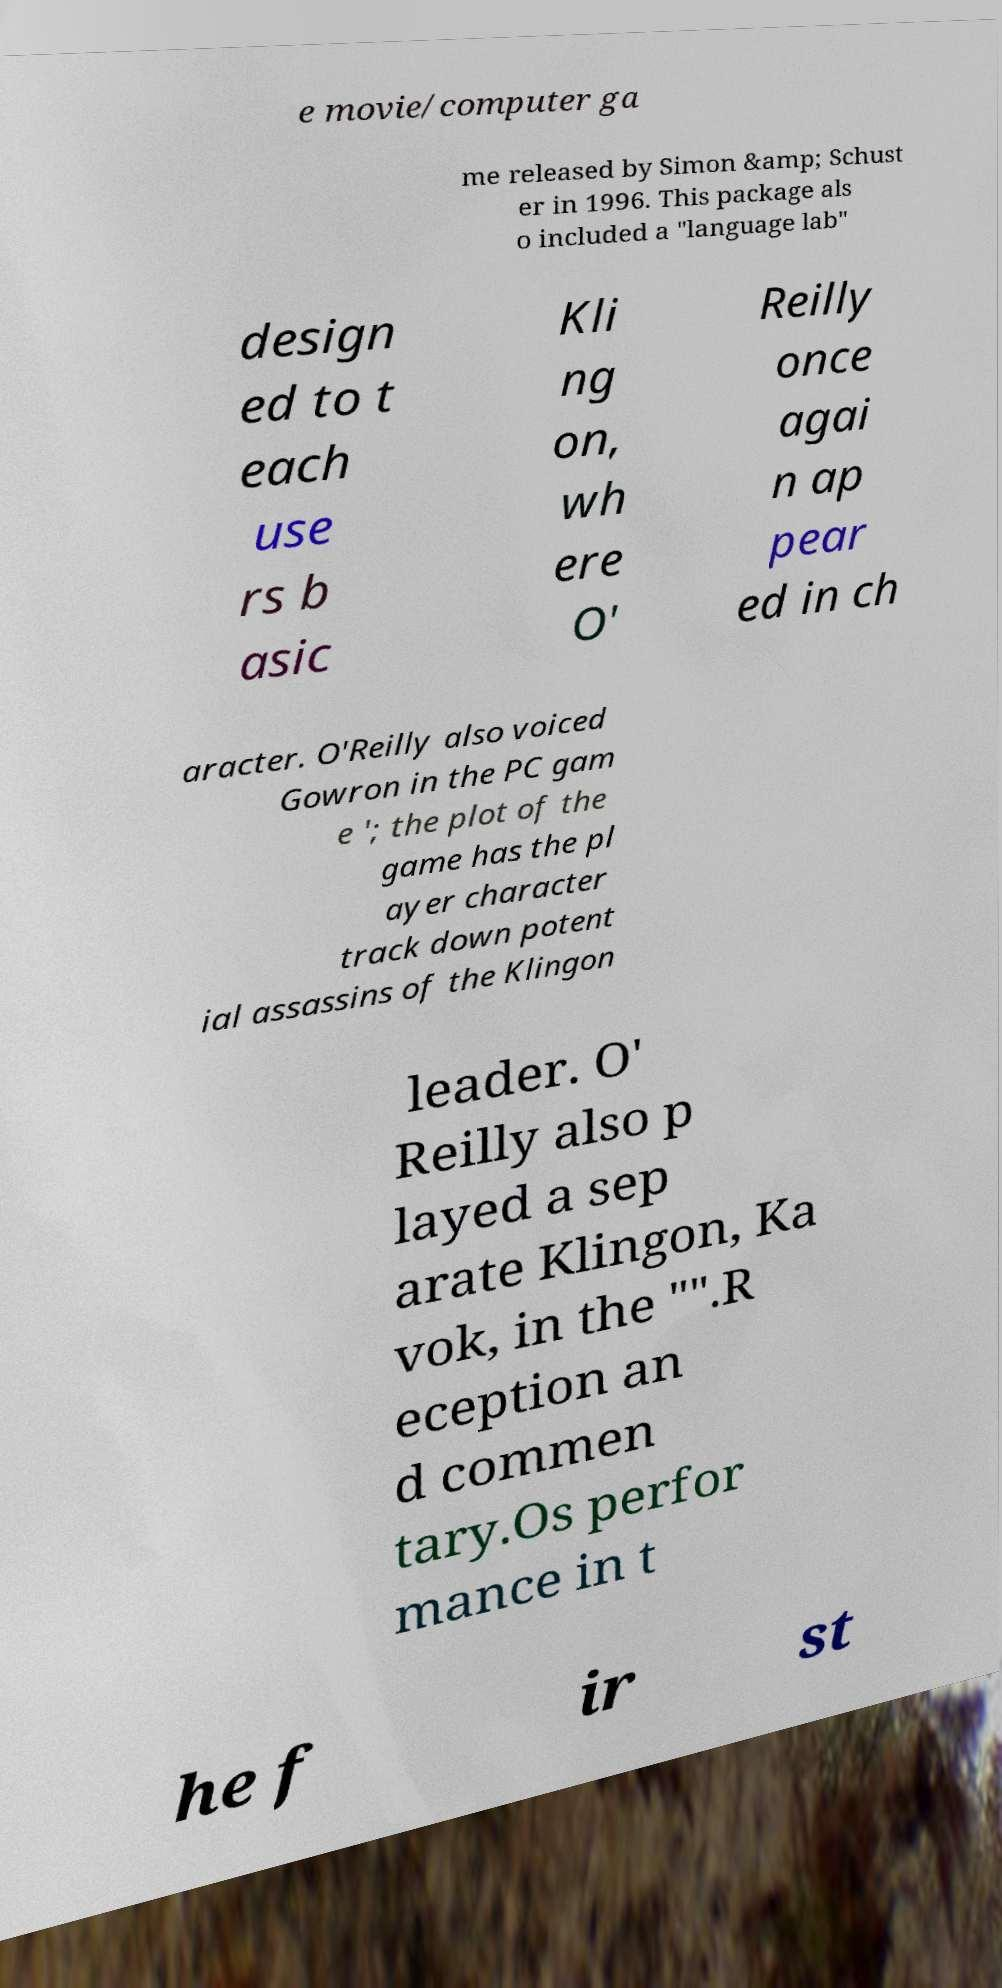Please identify and transcribe the text found in this image. e movie/computer ga me released by Simon &amp; Schust er in 1996. This package als o included a "language lab" design ed to t each use rs b asic Kli ng on, wh ere O' Reilly once agai n ap pear ed in ch aracter. O'Reilly also voiced Gowron in the PC gam e '; the plot of the game has the pl ayer character track down potent ial assassins of the Klingon leader. O' Reilly also p layed a sep arate Klingon, Ka vok, in the "".R eception an d commen tary.Os perfor mance in t he f ir st 